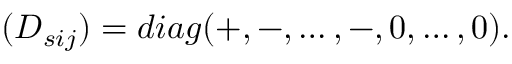Convert formula to latex. <formula><loc_0><loc_0><loc_500><loc_500>( D _ { s i j } ) = d i a g ( + , - , \dots , - , 0 , \dots , 0 ) .</formula> 